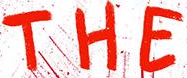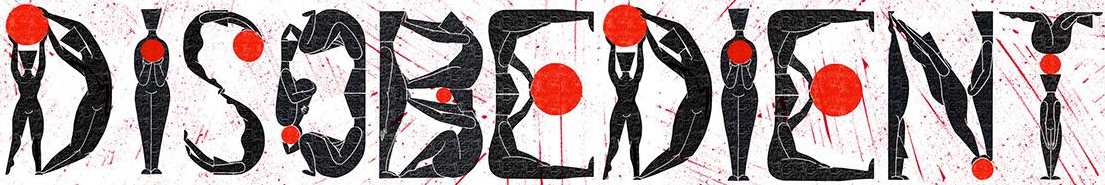Identify the words shown in these images in order, separated by a semicolon. THE; DISOBEDIENT 